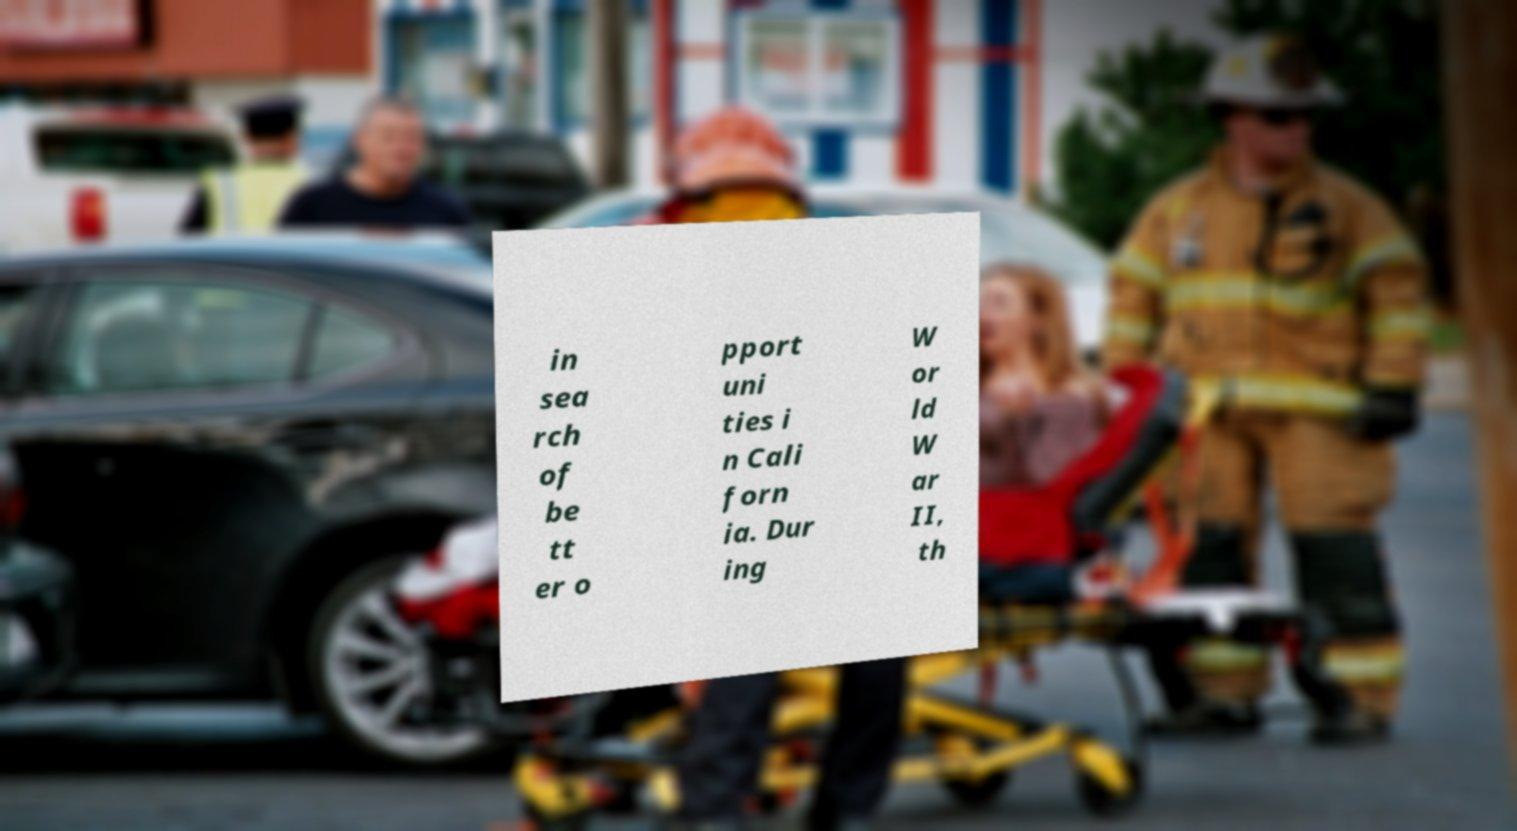Could you assist in decoding the text presented in this image and type it out clearly? in sea rch of be tt er o pport uni ties i n Cali forn ia. Dur ing W or ld W ar II, th 